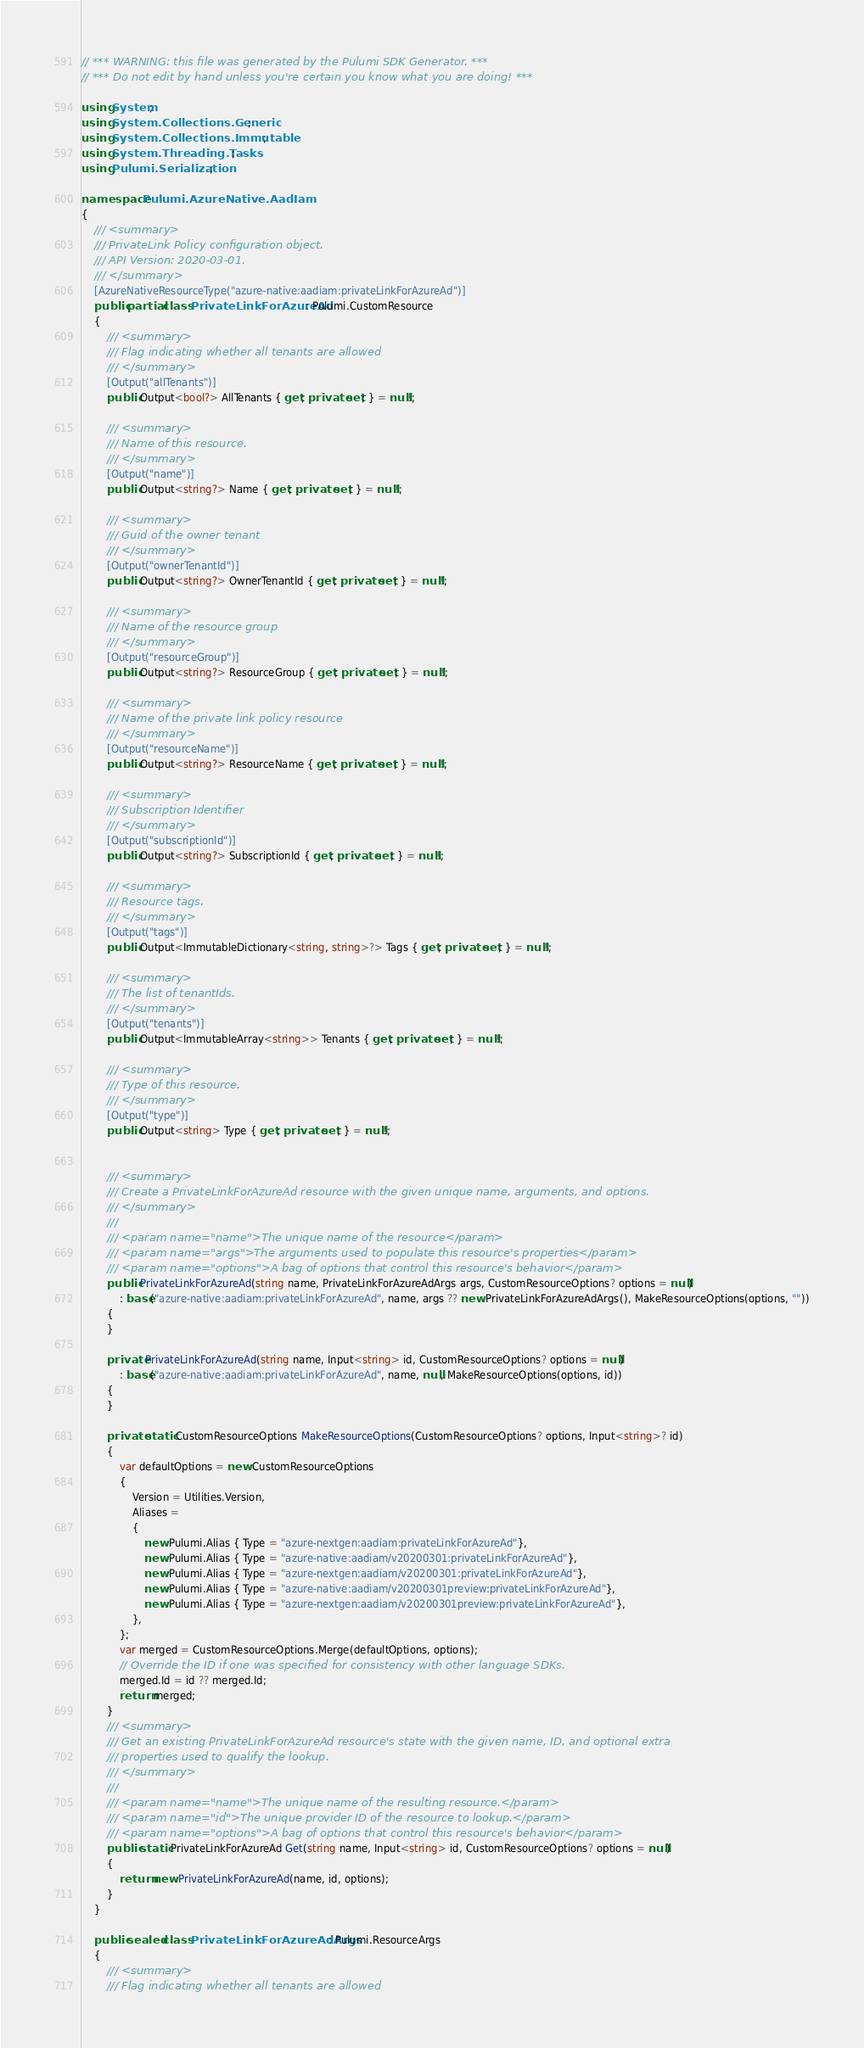<code> <loc_0><loc_0><loc_500><loc_500><_C#_>// *** WARNING: this file was generated by the Pulumi SDK Generator. ***
// *** Do not edit by hand unless you're certain you know what you are doing! ***

using System;
using System.Collections.Generic;
using System.Collections.Immutable;
using System.Threading.Tasks;
using Pulumi.Serialization;

namespace Pulumi.AzureNative.AadIam
{
    /// <summary>
    /// PrivateLink Policy configuration object.
    /// API Version: 2020-03-01.
    /// </summary>
    [AzureNativeResourceType("azure-native:aadiam:privateLinkForAzureAd")]
    public partial class PrivateLinkForAzureAd : Pulumi.CustomResource
    {
        /// <summary>
        /// Flag indicating whether all tenants are allowed
        /// </summary>
        [Output("allTenants")]
        public Output<bool?> AllTenants { get; private set; } = null!;

        /// <summary>
        /// Name of this resource.
        /// </summary>
        [Output("name")]
        public Output<string?> Name { get; private set; } = null!;

        /// <summary>
        /// Guid of the owner tenant
        /// </summary>
        [Output("ownerTenantId")]
        public Output<string?> OwnerTenantId { get; private set; } = null!;

        /// <summary>
        /// Name of the resource group
        /// </summary>
        [Output("resourceGroup")]
        public Output<string?> ResourceGroup { get; private set; } = null!;

        /// <summary>
        /// Name of the private link policy resource
        /// </summary>
        [Output("resourceName")]
        public Output<string?> ResourceName { get; private set; } = null!;

        /// <summary>
        /// Subscription Identifier
        /// </summary>
        [Output("subscriptionId")]
        public Output<string?> SubscriptionId { get; private set; } = null!;

        /// <summary>
        /// Resource tags.
        /// </summary>
        [Output("tags")]
        public Output<ImmutableDictionary<string, string>?> Tags { get; private set; } = null!;

        /// <summary>
        /// The list of tenantIds.
        /// </summary>
        [Output("tenants")]
        public Output<ImmutableArray<string>> Tenants { get; private set; } = null!;

        /// <summary>
        /// Type of this resource.
        /// </summary>
        [Output("type")]
        public Output<string> Type { get; private set; } = null!;


        /// <summary>
        /// Create a PrivateLinkForAzureAd resource with the given unique name, arguments, and options.
        /// </summary>
        ///
        /// <param name="name">The unique name of the resource</param>
        /// <param name="args">The arguments used to populate this resource's properties</param>
        /// <param name="options">A bag of options that control this resource's behavior</param>
        public PrivateLinkForAzureAd(string name, PrivateLinkForAzureAdArgs args, CustomResourceOptions? options = null)
            : base("azure-native:aadiam:privateLinkForAzureAd", name, args ?? new PrivateLinkForAzureAdArgs(), MakeResourceOptions(options, ""))
        {
        }

        private PrivateLinkForAzureAd(string name, Input<string> id, CustomResourceOptions? options = null)
            : base("azure-native:aadiam:privateLinkForAzureAd", name, null, MakeResourceOptions(options, id))
        {
        }

        private static CustomResourceOptions MakeResourceOptions(CustomResourceOptions? options, Input<string>? id)
        {
            var defaultOptions = new CustomResourceOptions
            {
                Version = Utilities.Version,
                Aliases =
                {
                    new Pulumi.Alias { Type = "azure-nextgen:aadiam:privateLinkForAzureAd"},
                    new Pulumi.Alias { Type = "azure-native:aadiam/v20200301:privateLinkForAzureAd"},
                    new Pulumi.Alias { Type = "azure-nextgen:aadiam/v20200301:privateLinkForAzureAd"},
                    new Pulumi.Alias { Type = "azure-native:aadiam/v20200301preview:privateLinkForAzureAd"},
                    new Pulumi.Alias { Type = "azure-nextgen:aadiam/v20200301preview:privateLinkForAzureAd"},
                },
            };
            var merged = CustomResourceOptions.Merge(defaultOptions, options);
            // Override the ID if one was specified for consistency with other language SDKs.
            merged.Id = id ?? merged.Id;
            return merged;
        }
        /// <summary>
        /// Get an existing PrivateLinkForAzureAd resource's state with the given name, ID, and optional extra
        /// properties used to qualify the lookup.
        /// </summary>
        ///
        /// <param name="name">The unique name of the resulting resource.</param>
        /// <param name="id">The unique provider ID of the resource to lookup.</param>
        /// <param name="options">A bag of options that control this resource's behavior</param>
        public static PrivateLinkForAzureAd Get(string name, Input<string> id, CustomResourceOptions? options = null)
        {
            return new PrivateLinkForAzureAd(name, id, options);
        }
    }

    public sealed class PrivateLinkForAzureAdArgs : Pulumi.ResourceArgs
    {
        /// <summary>
        /// Flag indicating whether all tenants are allowed</code> 